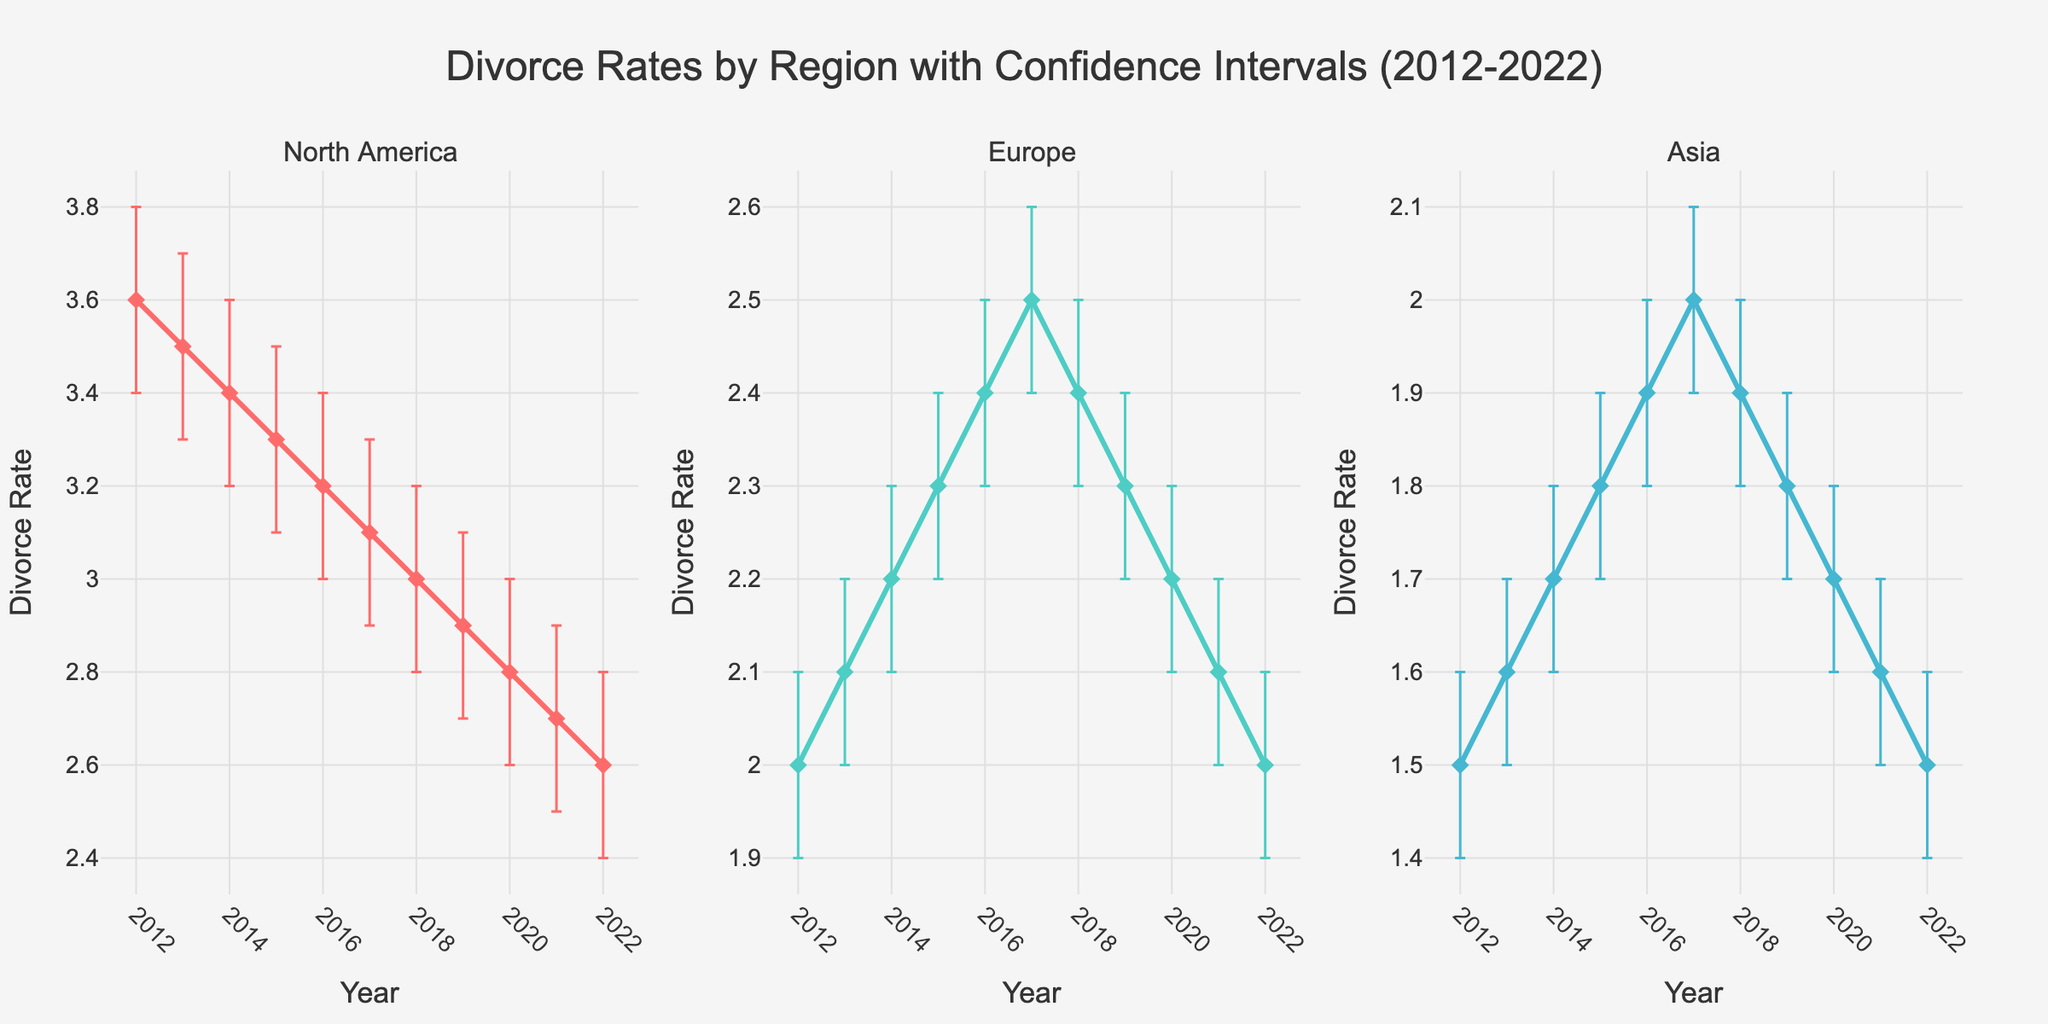What is the title of the figure? The title is the text that is prominently displayed at the top of the figure, and it encapsulates the overall theme or subject being depicted. In this case, it is located in the center at the top.
Answer: Divorce Rates by Region with Confidence Intervals (2012-2022) Which region had the highest divorce rate in 2012? To determine this, look at the starting points of the lines for each region at 2012. North America's line starts at a higher value compared to Europe and Asia.
Answer: North America Did the divorce rate in North America increase or decrease over the decade? Observe the trend of the line representing North America from 2012 to 2022. It starts at a higher value and declines steadily over the years.
Answer: Decrease What region had the smallest range of confidence intervals on average? Compare the widths of the error bars for each region across the entire time span. Europe’s error bars seem consistently narrower compared to North America and Asia.
Answer: Europe In which year did Asia experience its peak divorce rate? Locate the peak point on the line representing Asia across the years. The highest point for the Asia line is in 2017.
Answer: 2017 By how much did the divorce rate in Europe decrease from its peak to 2022? Identify Europe's maximum rate (2017) and subtract the rate for 2022. The peak in 2017 was 2.5, and the rate in 2022 was 2.0. The difference is 2.5 - 2.0.
Answer: 0.5 Compare the trends in divorce rates between Europe and Asia from 2012 to 2022. Analysing the trajectory of the lines, Europe shows a peak around 2017 and then a decline back to its initial rate, while Asia generally increases up to 2017 and then returns to its starting point.
Answer: Europe peaks then returns, Asia steadily rises then retreats Which year shows the narrowest confidence interval range for North America? Examine the error bars for North America across all years; the smallest error bar range appears at 2022.
Answer: 2022 How does the divorce rate trend in Asia compare to that in North America from 2017 onward? Post-2017, observe that both North America and Asia experience a decline in their divorce rates.
Answer: Both decline What year did both Europe and Asia exhibit the same divorce rate? Locate where the lines for Europe and Asia intersect. Both regions show identical values in 2017.
Answer: 2017 